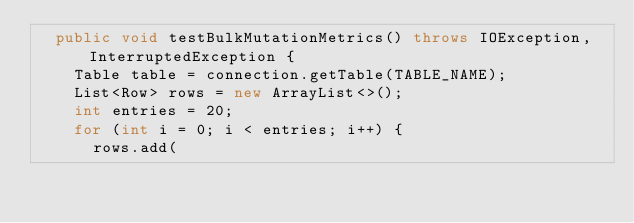Convert code to text. <code><loc_0><loc_0><loc_500><loc_500><_Java_>  public void testBulkMutationMetrics() throws IOException, InterruptedException {
    Table table = connection.getTable(TABLE_NAME);
    List<Row> rows = new ArrayList<>();
    int entries = 20;
    for (int i = 0; i < entries; i++) {
      rows.add(</code> 